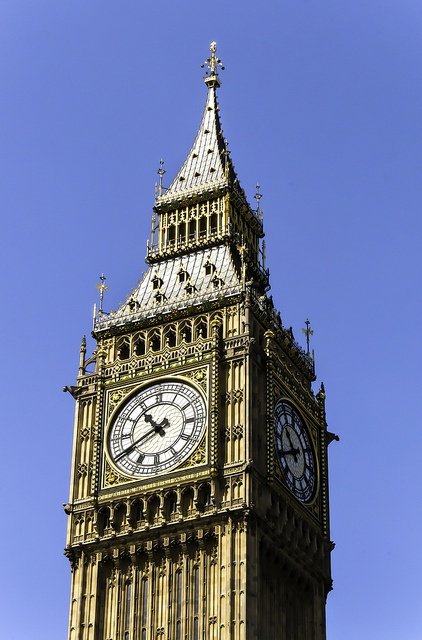Describe the objects in this image and their specific colors. I can see clock in lightblue, white, gray, black, and darkgray tones and clock in lightblue, black, and gray tones in this image. 